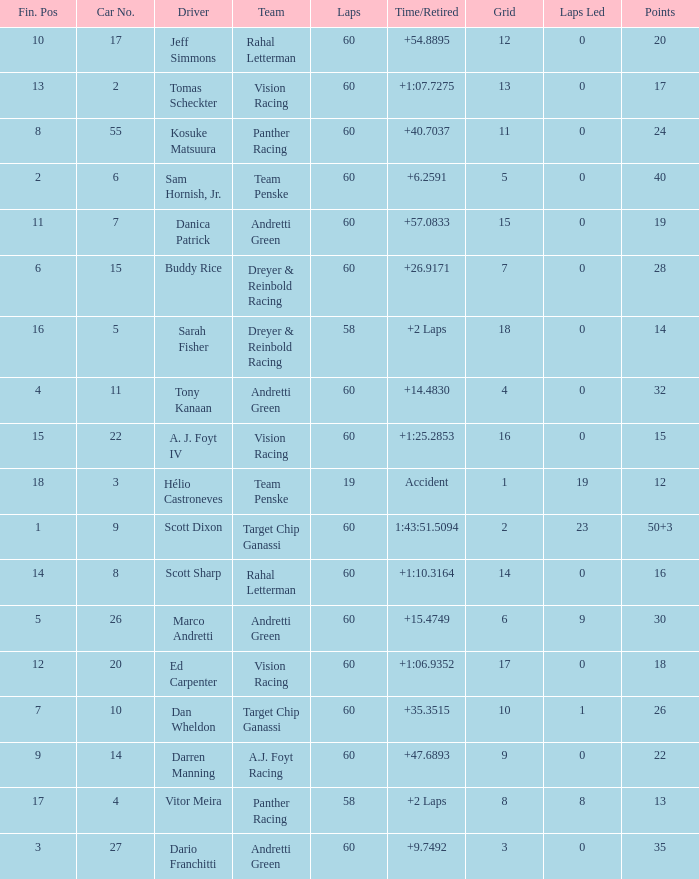Name the team of darren manning A.J. Foyt Racing. 